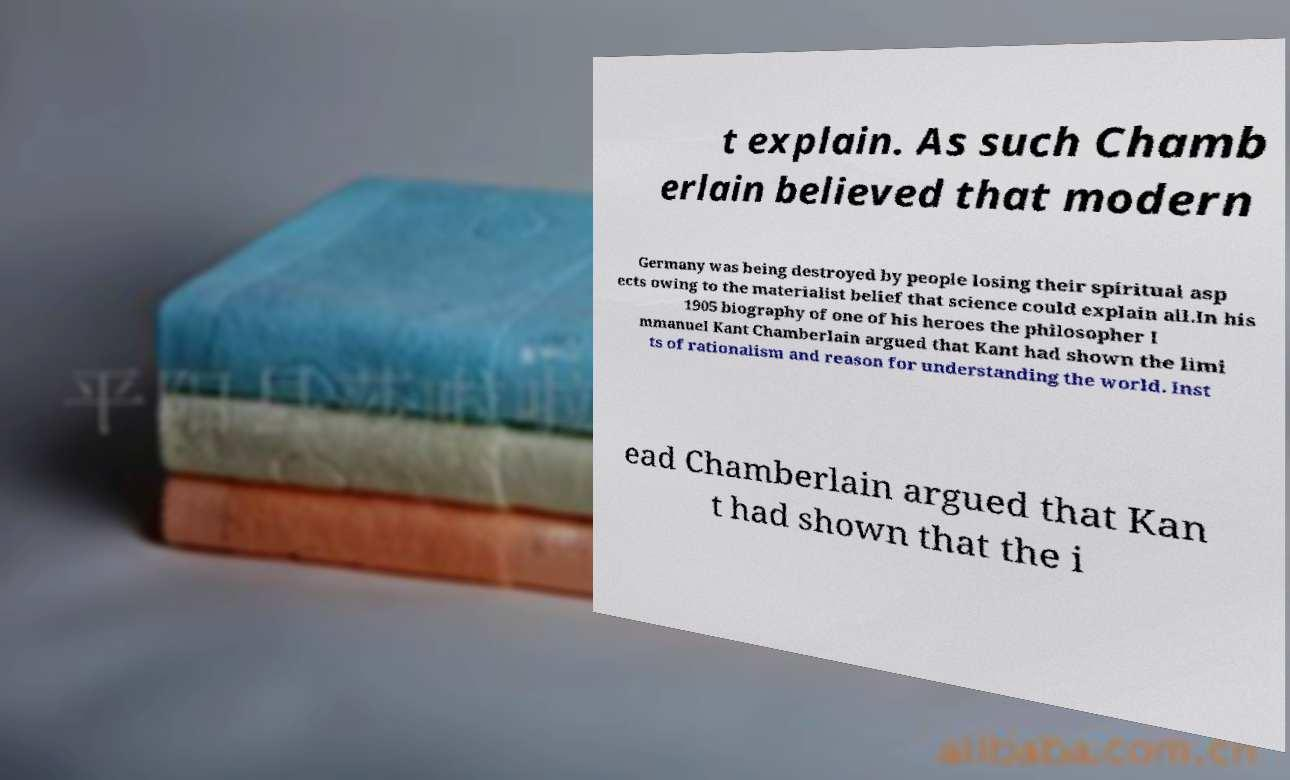What messages or text are displayed in this image? I need them in a readable, typed format. t explain. As such Chamb erlain believed that modern Germany was being destroyed by people losing their spiritual asp ects owing to the materialist belief that science could explain all.In his 1905 biography of one of his heroes the philosopher I mmanuel Kant Chamberlain argued that Kant had shown the limi ts of rationalism and reason for understanding the world. Inst ead Chamberlain argued that Kan t had shown that the i 